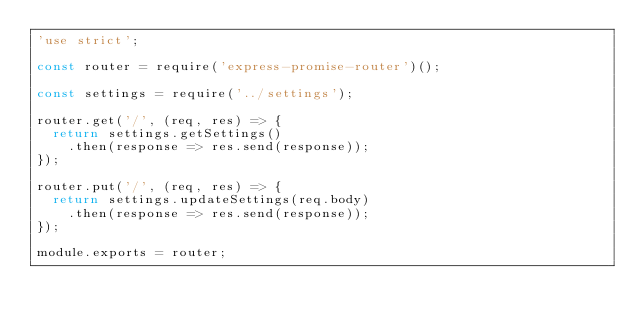Convert code to text. <code><loc_0><loc_0><loc_500><loc_500><_JavaScript_>'use strict';

const router = require('express-promise-router')();

const settings = require('../settings');

router.get('/', (req, res) => {
	return settings.getSettings()
		.then(response => res.send(response));
});

router.put('/', (req, res) => {
	return settings.updateSettings(req.body)
		.then(response => res.send(response));
});

module.exports = router;
</code> 